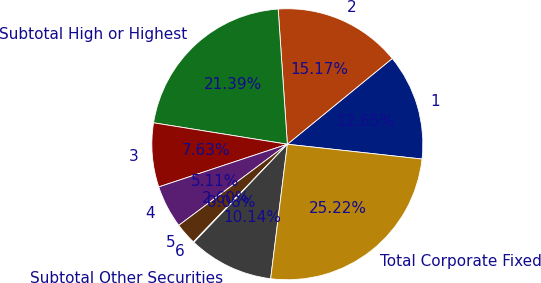Convert chart. <chart><loc_0><loc_0><loc_500><loc_500><pie_chart><fcel>1<fcel>2<fcel>Subtotal High or Highest<fcel>3<fcel>4<fcel>5<fcel>6<fcel>Subtotal Other Securities<fcel>Total Corporate Fixed<nl><fcel>12.65%<fcel>15.17%<fcel>21.39%<fcel>7.63%<fcel>5.11%<fcel>2.6%<fcel>0.08%<fcel>10.14%<fcel>25.22%<nl></chart> 